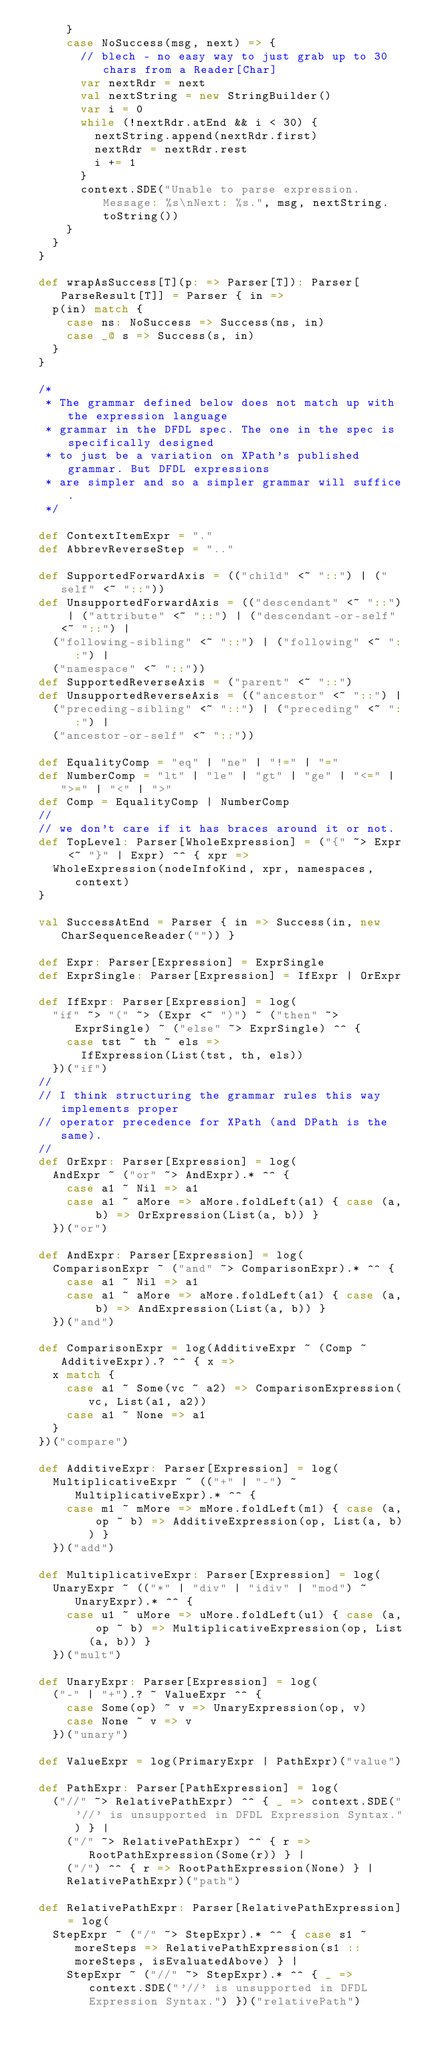<code> <loc_0><loc_0><loc_500><loc_500><_Scala_>      }
      case NoSuccess(msg, next) => {
        // blech - no easy way to just grab up to 30 chars from a Reader[Char]
        var nextRdr = next
        val nextString = new StringBuilder()
        var i = 0
        while (!nextRdr.atEnd && i < 30) {
          nextString.append(nextRdr.first)
          nextRdr = nextRdr.rest
          i += 1
        }
        context.SDE("Unable to parse expression. Message: %s\nNext: %s.", msg, nextString.toString())
      }
    }
  }

  def wrapAsSuccess[T](p: => Parser[T]): Parser[ParseResult[T]] = Parser { in =>
    p(in) match {
      case ns: NoSuccess => Success(ns, in)
      case _@ s => Success(s, in)
    }
  }

  /*
   * The grammar defined below does not match up with the expression language
   * grammar in the DFDL spec. The one in the spec is specifically designed
   * to just be a variation on XPath's published grammar. But DFDL expressions
   * are simpler and so a simpler grammar will suffice.
   */

  def ContextItemExpr = "."
  def AbbrevReverseStep = ".."

  def SupportedForwardAxis = (("child" <~ "::") | ("self" <~ "::"))
  def UnsupportedForwardAxis = (("descendant" <~ "::") | ("attribute" <~ "::") | ("descendant-or-self" <~ "::") |
    ("following-sibling" <~ "::") | ("following" <~ "::") |
    ("namespace" <~ "::"))
  def SupportedReverseAxis = ("parent" <~ "::")
  def UnsupportedReverseAxis = (("ancestor" <~ "::") |
    ("preceding-sibling" <~ "::") | ("preceding" <~ "::") |
    ("ancestor-or-self" <~ "::"))

  def EqualityComp = "eq" | "ne" | "!=" | "="
  def NumberComp = "lt" | "le" | "gt" | "ge" | "<=" | ">=" | "<" | ">"
  def Comp = EqualityComp | NumberComp
  //
  // we don't care if it has braces around it or not.
  def TopLevel: Parser[WholeExpression] = ("{" ~> Expr <~ "}" | Expr) ^^ { xpr =>
    WholeExpression(nodeInfoKind, xpr, namespaces, context)
  }

  val SuccessAtEnd = Parser { in => Success(in, new CharSequenceReader("")) }

  def Expr: Parser[Expression] = ExprSingle
  def ExprSingle: Parser[Expression] = IfExpr | OrExpr

  def IfExpr: Parser[Expression] = log(
    "if" ~> "(" ~> (Expr <~ ")") ~ ("then" ~> ExprSingle) ~ ("else" ~> ExprSingle) ^^ {
      case tst ~ th ~ els =>
        IfExpression(List(tst, th, els))
    })("if")
  //
  // I think structuring the grammar rules this way implements proper
  // operator precedence for XPath (and DPath is the same).
  //
  def OrExpr: Parser[Expression] = log(
    AndExpr ~ ("or" ~> AndExpr).* ^^ {
      case a1 ~ Nil => a1
      case a1 ~ aMore => aMore.foldLeft(a1) { case (a, b) => OrExpression(List(a, b)) }
    })("or")

  def AndExpr: Parser[Expression] = log(
    ComparisonExpr ~ ("and" ~> ComparisonExpr).* ^^ {
      case a1 ~ Nil => a1
      case a1 ~ aMore => aMore.foldLeft(a1) { case (a, b) => AndExpression(List(a, b)) }
    })("and")

  def ComparisonExpr = log(AdditiveExpr ~ (Comp ~ AdditiveExpr).? ^^ { x =>
    x match {
      case a1 ~ Some(vc ~ a2) => ComparisonExpression(vc, List(a1, a2))
      case a1 ~ None => a1
    }
  })("compare")

  def AdditiveExpr: Parser[Expression] = log(
    MultiplicativeExpr ~ (("+" | "-") ~ MultiplicativeExpr).* ^^ {
      case m1 ~ mMore => mMore.foldLeft(m1) { case (a, op ~ b) => AdditiveExpression(op, List(a, b)) }
    })("add")

  def MultiplicativeExpr: Parser[Expression] = log(
    UnaryExpr ~ (("*" | "div" | "idiv" | "mod") ~ UnaryExpr).* ^^ {
      case u1 ~ uMore => uMore.foldLeft(u1) { case (a, op ~ b) => MultiplicativeExpression(op, List(a, b)) }
    })("mult")

  def UnaryExpr: Parser[Expression] = log(
    ("-" | "+").? ~ ValueExpr ^^ {
      case Some(op) ~ v => UnaryExpression(op, v)
      case None ~ v => v
    })("unary")

  def ValueExpr = log(PrimaryExpr | PathExpr)("value")

  def PathExpr: Parser[PathExpression] = log(
    ("//" ~> RelativePathExpr) ^^ { _ => context.SDE("'//' is unsupported in DFDL Expression Syntax.") } |
      ("/" ~> RelativePathExpr) ^^ { r => RootPathExpression(Some(r)) } |
      ("/") ^^ { r => RootPathExpression(None) } |
      RelativePathExpr)("path")

  def RelativePathExpr: Parser[RelativePathExpression] = log(
    StepExpr ~ ("/" ~> StepExpr).* ^^ { case s1 ~ moreSteps => RelativePathExpression(s1 :: moreSteps, isEvaluatedAbove) } |
      StepExpr ~ ("//" ~> StepExpr).* ^^ { _ => context.SDE("'//' is unsupported in DFDL Expression Syntax.") })("relativePath")
</code> 